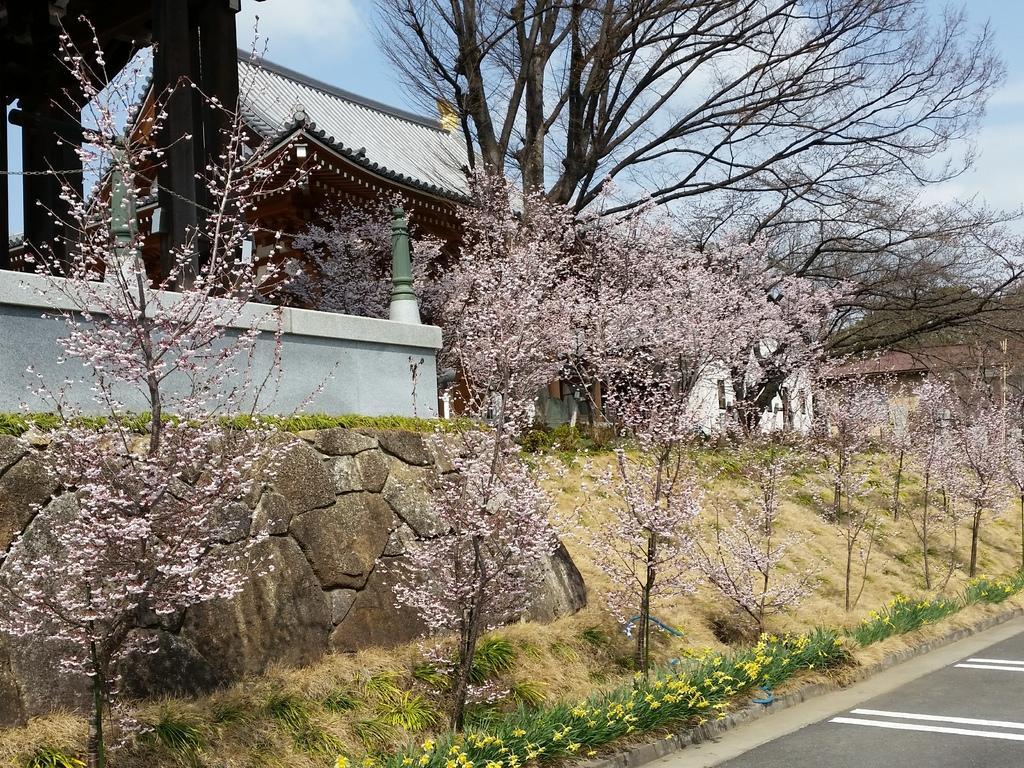How would you summarize this image in a sentence or two? In the foreground of this image, there is a road, few flowers, grass, trees and few houses. At the top, there is the sky. 